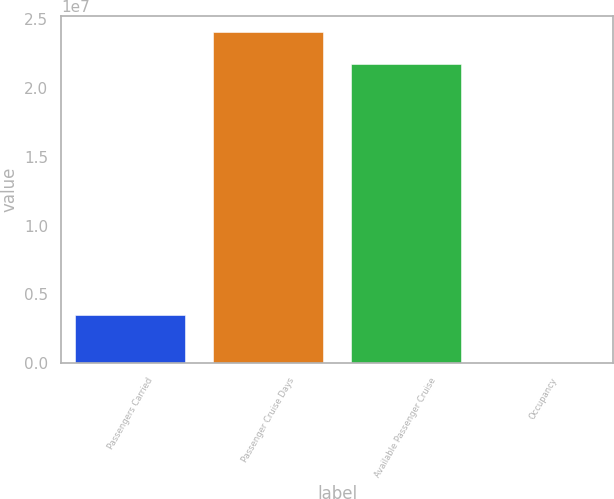Convert chart to OTSL. <chart><loc_0><loc_0><loc_500><loc_500><bar_chart><fcel>Passengers Carried<fcel>Passenger Cruise Days<fcel>Available Passenger Cruise<fcel>Occupancy<nl><fcel>3.47629e+06<fcel>2.40516e+07<fcel>2.17337e+07<fcel>106.6<nl></chart> 